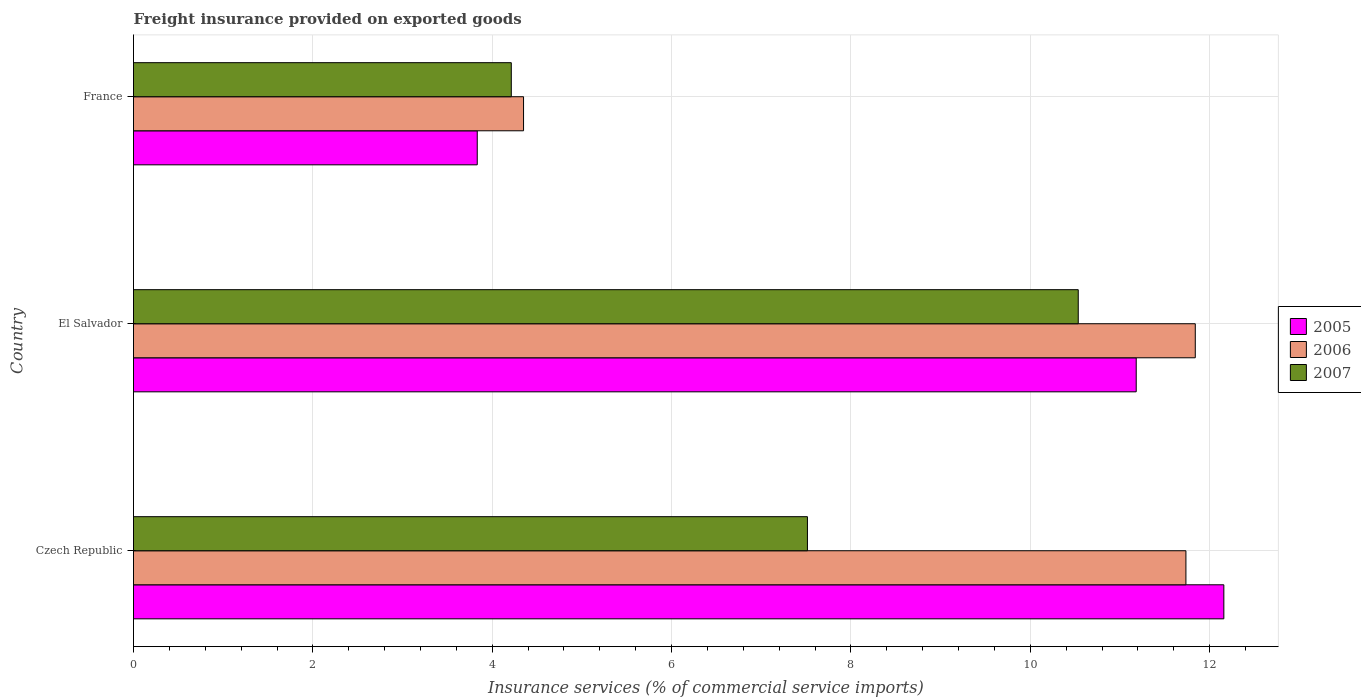How many groups of bars are there?
Provide a short and direct response. 3. Are the number of bars per tick equal to the number of legend labels?
Make the answer very short. Yes. What is the label of the 2nd group of bars from the top?
Offer a terse response. El Salvador. In how many cases, is the number of bars for a given country not equal to the number of legend labels?
Offer a very short reply. 0. What is the freight insurance provided on exported goods in 2006 in France?
Keep it short and to the point. 4.35. Across all countries, what is the maximum freight insurance provided on exported goods in 2007?
Provide a short and direct response. 10.53. Across all countries, what is the minimum freight insurance provided on exported goods in 2007?
Provide a succinct answer. 4.21. In which country was the freight insurance provided on exported goods in 2005 maximum?
Your answer should be compact. Czech Republic. What is the total freight insurance provided on exported goods in 2006 in the graph?
Your answer should be very brief. 27.92. What is the difference between the freight insurance provided on exported goods in 2005 in El Salvador and that in France?
Your answer should be compact. 7.35. What is the difference between the freight insurance provided on exported goods in 2007 in El Salvador and the freight insurance provided on exported goods in 2005 in Czech Republic?
Keep it short and to the point. -1.62. What is the average freight insurance provided on exported goods in 2005 per country?
Your response must be concise. 9.06. What is the difference between the freight insurance provided on exported goods in 2007 and freight insurance provided on exported goods in 2006 in Czech Republic?
Ensure brevity in your answer.  -4.22. What is the ratio of the freight insurance provided on exported goods in 2005 in Czech Republic to that in El Salvador?
Ensure brevity in your answer.  1.09. What is the difference between the highest and the second highest freight insurance provided on exported goods in 2005?
Make the answer very short. 0.98. What is the difference between the highest and the lowest freight insurance provided on exported goods in 2007?
Your answer should be compact. 6.32. Is the sum of the freight insurance provided on exported goods in 2006 in El Salvador and France greater than the maximum freight insurance provided on exported goods in 2007 across all countries?
Provide a succinct answer. Yes. What does the 3rd bar from the top in El Salvador represents?
Offer a very short reply. 2005. What does the 2nd bar from the bottom in France represents?
Provide a succinct answer. 2006. Is it the case that in every country, the sum of the freight insurance provided on exported goods in 2007 and freight insurance provided on exported goods in 2006 is greater than the freight insurance provided on exported goods in 2005?
Give a very brief answer. Yes. Are all the bars in the graph horizontal?
Ensure brevity in your answer.  Yes. How many countries are there in the graph?
Your answer should be very brief. 3. Are the values on the major ticks of X-axis written in scientific E-notation?
Provide a succinct answer. No. How many legend labels are there?
Offer a very short reply. 3. What is the title of the graph?
Offer a very short reply. Freight insurance provided on exported goods. What is the label or title of the X-axis?
Provide a short and direct response. Insurance services (% of commercial service imports). What is the label or title of the Y-axis?
Keep it short and to the point. Country. What is the Insurance services (% of commercial service imports) in 2005 in Czech Republic?
Ensure brevity in your answer.  12.16. What is the Insurance services (% of commercial service imports) in 2006 in Czech Republic?
Ensure brevity in your answer.  11.73. What is the Insurance services (% of commercial service imports) in 2007 in Czech Republic?
Give a very brief answer. 7.51. What is the Insurance services (% of commercial service imports) in 2005 in El Salvador?
Keep it short and to the point. 11.18. What is the Insurance services (% of commercial service imports) of 2006 in El Salvador?
Your answer should be very brief. 11.84. What is the Insurance services (% of commercial service imports) in 2007 in El Salvador?
Provide a short and direct response. 10.53. What is the Insurance services (% of commercial service imports) in 2005 in France?
Your answer should be very brief. 3.83. What is the Insurance services (% of commercial service imports) in 2006 in France?
Offer a very short reply. 4.35. What is the Insurance services (% of commercial service imports) of 2007 in France?
Your answer should be very brief. 4.21. Across all countries, what is the maximum Insurance services (% of commercial service imports) of 2005?
Your response must be concise. 12.16. Across all countries, what is the maximum Insurance services (% of commercial service imports) in 2006?
Your response must be concise. 11.84. Across all countries, what is the maximum Insurance services (% of commercial service imports) of 2007?
Keep it short and to the point. 10.53. Across all countries, what is the minimum Insurance services (% of commercial service imports) in 2005?
Offer a terse response. 3.83. Across all countries, what is the minimum Insurance services (% of commercial service imports) in 2006?
Make the answer very short. 4.35. Across all countries, what is the minimum Insurance services (% of commercial service imports) of 2007?
Make the answer very short. 4.21. What is the total Insurance services (% of commercial service imports) in 2005 in the graph?
Keep it short and to the point. 27.17. What is the total Insurance services (% of commercial service imports) in 2006 in the graph?
Your response must be concise. 27.92. What is the total Insurance services (% of commercial service imports) of 2007 in the graph?
Offer a terse response. 22.26. What is the difference between the Insurance services (% of commercial service imports) in 2005 in Czech Republic and that in El Salvador?
Offer a very short reply. 0.98. What is the difference between the Insurance services (% of commercial service imports) in 2006 in Czech Republic and that in El Salvador?
Offer a terse response. -0.1. What is the difference between the Insurance services (% of commercial service imports) of 2007 in Czech Republic and that in El Salvador?
Your answer should be compact. -3.02. What is the difference between the Insurance services (% of commercial service imports) in 2005 in Czech Republic and that in France?
Ensure brevity in your answer.  8.32. What is the difference between the Insurance services (% of commercial service imports) of 2006 in Czech Republic and that in France?
Make the answer very short. 7.39. What is the difference between the Insurance services (% of commercial service imports) of 2007 in Czech Republic and that in France?
Offer a very short reply. 3.3. What is the difference between the Insurance services (% of commercial service imports) of 2005 in El Salvador and that in France?
Provide a short and direct response. 7.35. What is the difference between the Insurance services (% of commercial service imports) in 2006 in El Salvador and that in France?
Give a very brief answer. 7.49. What is the difference between the Insurance services (% of commercial service imports) in 2007 in El Salvador and that in France?
Your response must be concise. 6.32. What is the difference between the Insurance services (% of commercial service imports) in 2005 in Czech Republic and the Insurance services (% of commercial service imports) in 2006 in El Salvador?
Keep it short and to the point. 0.32. What is the difference between the Insurance services (% of commercial service imports) in 2005 in Czech Republic and the Insurance services (% of commercial service imports) in 2007 in El Salvador?
Ensure brevity in your answer.  1.62. What is the difference between the Insurance services (% of commercial service imports) in 2006 in Czech Republic and the Insurance services (% of commercial service imports) in 2007 in El Salvador?
Offer a terse response. 1.2. What is the difference between the Insurance services (% of commercial service imports) of 2005 in Czech Republic and the Insurance services (% of commercial service imports) of 2006 in France?
Give a very brief answer. 7.81. What is the difference between the Insurance services (% of commercial service imports) in 2005 in Czech Republic and the Insurance services (% of commercial service imports) in 2007 in France?
Provide a short and direct response. 7.95. What is the difference between the Insurance services (% of commercial service imports) in 2006 in Czech Republic and the Insurance services (% of commercial service imports) in 2007 in France?
Give a very brief answer. 7.52. What is the difference between the Insurance services (% of commercial service imports) in 2005 in El Salvador and the Insurance services (% of commercial service imports) in 2006 in France?
Your answer should be compact. 6.83. What is the difference between the Insurance services (% of commercial service imports) of 2005 in El Salvador and the Insurance services (% of commercial service imports) of 2007 in France?
Provide a short and direct response. 6.97. What is the difference between the Insurance services (% of commercial service imports) of 2006 in El Salvador and the Insurance services (% of commercial service imports) of 2007 in France?
Ensure brevity in your answer.  7.63. What is the average Insurance services (% of commercial service imports) of 2005 per country?
Provide a succinct answer. 9.06. What is the average Insurance services (% of commercial service imports) of 2006 per country?
Your answer should be compact. 9.31. What is the average Insurance services (% of commercial service imports) of 2007 per country?
Keep it short and to the point. 7.42. What is the difference between the Insurance services (% of commercial service imports) in 2005 and Insurance services (% of commercial service imports) in 2006 in Czech Republic?
Your answer should be very brief. 0.42. What is the difference between the Insurance services (% of commercial service imports) in 2005 and Insurance services (% of commercial service imports) in 2007 in Czech Republic?
Ensure brevity in your answer.  4.64. What is the difference between the Insurance services (% of commercial service imports) of 2006 and Insurance services (% of commercial service imports) of 2007 in Czech Republic?
Provide a short and direct response. 4.22. What is the difference between the Insurance services (% of commercial service imports) of 2005 and Insurance services (% of commercial service imports) of 2006 in El Salvador?
Ensure brevity in your answer.  -0.66. What is the difference between the Insurance services (% of commercial service imports) of 2005 and Insurance services (% of commercial service imports) of 2007 in El Salvador?
Ensure brevity in your answer.  0.65. What is the difference between the Insurance services (% of commercial service imports) in 2006 and Insurance services (% of commercial service imports) in 2007 in El Salvador?
Make the answer very short. 1.3. What is the difference between the Insurance services (% of commercial service imports) of 2005 and Insurance services (% of commercial service imports) of 2006 in France?
Your answer should be compact. -0.52. What is the difference between the Insurance services (% of commercial service imports) of 2005 and Insurance services (% of commercial service imports) of 2007 in France?
Offer a very short reply. -0.38. What is the difference between the Insurance services (% of commercial service imports) of 2006 and Insurance services (% of commercial service imports) of 2007 in France?
Offer a very short reply. 0.14. What is the ratio of the Insurance services (% of commercial service imports) in 2005 in Czech Republic to that in El Salvador?
Give a very brief answer. 1.09. What is the ratio of the Insurance services (% of commercial service imports) of 2007 in Czech Republic to that in El Salvador?
Offer a very short reply. 0.71. What is the ratio of the Insurance services (% of commercial service imports) of 2005 in Czech Republic to that in France?
Offer a very short reply. 3.17. What is the ratio of the Insurance services (% of commercial service imports) in 2006 in Czech Republic to that in France?
Provide a short and direct response. 2.7. What is the ratio of the Insurance services (% of commercial service imports) in 2007 in Czech Republic to that in France?
Your response must be concise. 1.78. What is the ratio of the Insurance services (% of commercial service imports) of 2005 in El Salvador to that in France?
Your response must be concise. 2.92. What is the ratio of the Insurance services (% of commercial service imports) in 2006 in El Salvador to that in France?
Your answer should be compact. 2.72. What is the ratio of the Insurance services (% of commercial service imports) in 2007 in El Salvador to that in France?
Your answer should be compact. 2.5. What is the difference between the highest and the second highest Insurance services (% of commercial service imports) of 2005?
Your answer should be compact. 0.98. What is the difference between the highest and the second highest Insurance services (% of commercial service imports) in 2006?
Provide a succinct answer. 0.1. What is the difference between the highest and the second highest Insurance services (% of commercial service imports) of 2007?
Provide a succinct answer. 3.02. What is the difference between the highest and the lowest Insurance services (% of commercial service imports) in 2005?
Provide a short and direct response. 8.32. What is the difference between the highest and the lowest Insurance services (% of commercial service imports) in 2006?
Provide a short and direct response. 7.49. What is the difference between the highest and the lowest Insurance services (% of commercial service imports) of 2007?
Your answer should be very brief. 6.32. 